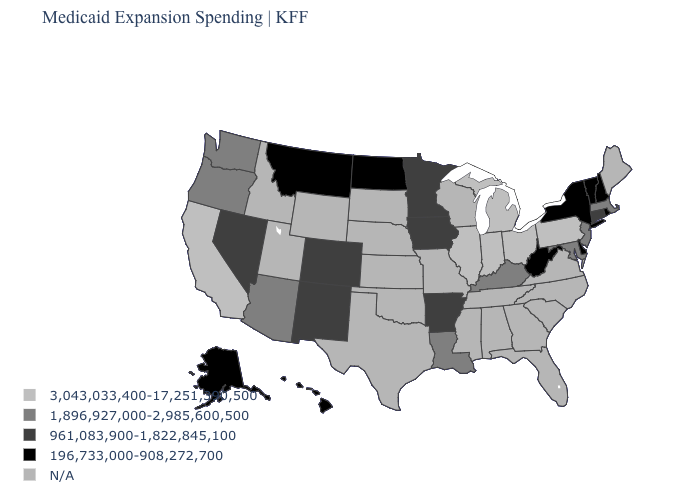What is the value of Colorado?
Short answer required. 961,083,900-1,822,845,100. Which states hav the highest value in the West?
Write a very short answer. California. Does the map have missing data?
Answer briefly. Yes. Name the states that have a value in the range 196,733,000-908,272,700?
Be succinct. Alaska, Delaware, Hawaii, Montana, New Hampshire, New York, North Dakota, Rhode Island, Vermont, West Virginia. What is the value of New Jersey?
Give a very brief answer. 1,896,927,000-2,985,600,500. Which states have the lowest value in the South?
Short answer required. Delaware, West Virginia. Which states have the lowest value in the USA?
Be succinct. Alaska, Delaware, Hawaii, Montana, New Hampshire, New York, North Dakota, Rhode Island, Vermont, West Virginia. Does the map have missing data?
Quick response, please. Yes. What is the value of Indiana?
Concise answer only. 3,043,033,400-17,251,390,500. Name the states that have a value in the range 196,733,000-908,272,700?
Short answer required. Alaska, Delaware, Hawaii, Montana, New Hampshire, New York, North Dakota, Rhode Island, Vermont, West Virginia. Does the first symbol in the legend represent the smallest category?
Give a very brief answer. No. Name the states that have a value in the range 3,043,033,400-17,251,390,500?
Quick response, please. California, Illinois, Indiana, Michigan, Ohio, Pennsylvania. Name the states that have a value in the range N/A?
Be succinct. Alabama, Florida, Georgia, Idaho, Kansas, Maine, Mississippi, Missouri, Nebraska, North Carolina, Oklahoma, South Carolina, South Dakota, Tennessee, Texas, Utah, Virginia, Wisconsin, Wyoming. 